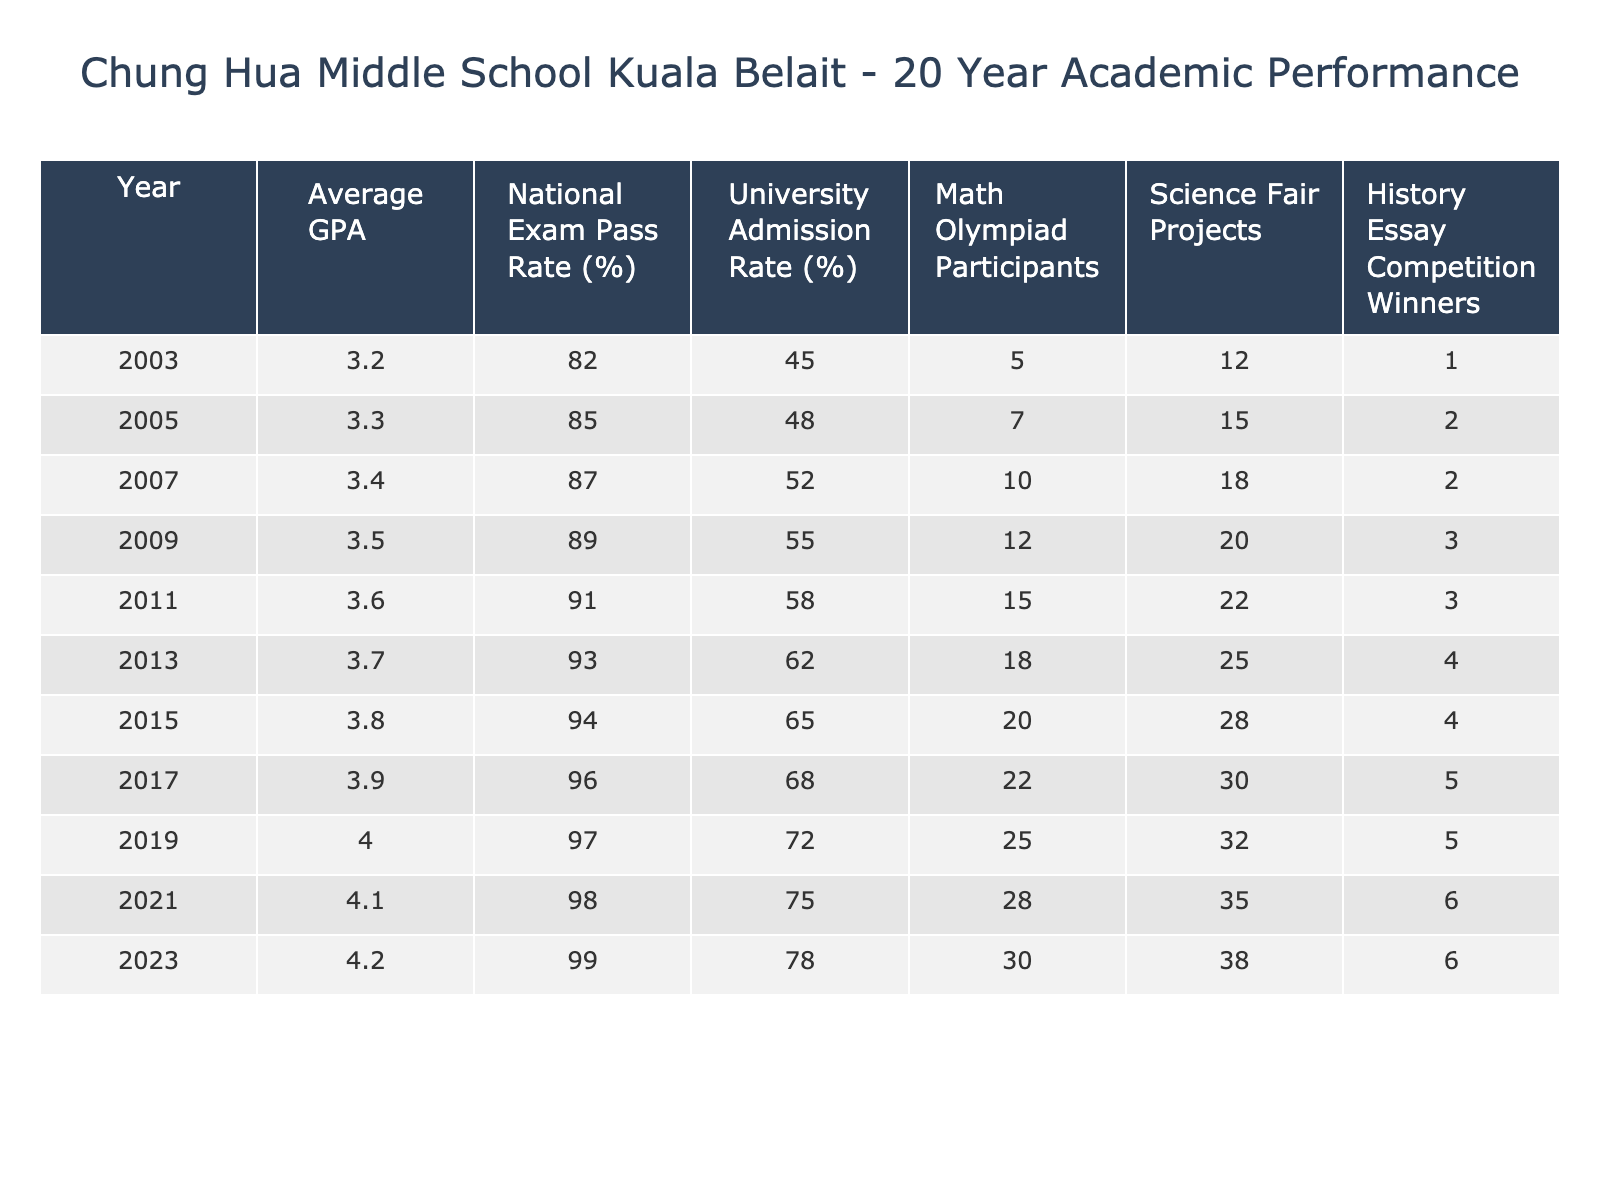What was the highest average GPA recorded in the past 20 years? From the table, the average GPAs range from 3.2 in 2003 to 4.2 in 2023. The maximum value is 4.2, which is the highest recorded average GPA.
Answer: 4.2 In which year did the National Exam Pass Rate reach 96%? By examining the table, the National Exam Pass Rates increase every two years. The value of 96% correlates with the year 2017.
Answer: 2017 What is the difference in the average GPA between 2003 and 2023? The average GPA in 2003 is 3.2 and in 2023 it is 4.2. To find the difference, subtract 3.2 from 4.2, resulting in 1.0.
Answer: 1.0 How many years had a University Admission Rate of 70% or more? The University Admission Rate reached 70% in 2019 and continued to increase in successive years until 2023. Counting these years includes 2019, 2021, and 2023, making a total of 4 years (2019, 2021, 2023).
Answer: 4 What is the average number of Math Olympiad participants over the 20 years? To determine the average, sum the values of Math Olympiad Participants: (5 + 7 + 10 + 12 + 15 + 18 + 20 + 22 + 25 + 28 + 30) =  4.5 per year with 11 total years gives an average of 20 participants.
Answer: 20 In which year did the History Essay Competition Winners peak? Looking through the data, the number of winners increased each year, reaching a peak of 6 winners in 2021 and 2023.
Answer: 2021 and 2023 What is the total number of Science Fair Projects recorded in the past years? By summing the values of Science Fair Projects: (12 + 15 + 18 + 20 + 22 + 25 + 28 + 30 + 32 + 35 + 38) =  251.
Answer: 251 Was there ever a year when both the National Exam Pass Rate and University Admission Rate were less than 80%? Checking the data, the National Exam Pass Rate was below 80% in 2003, but the University Admission Rate was over 40% that year, so the statement is false.
Answer: No How much did the Math Olympiad participants increase from 2011 to 2021? The number of Math Olympiad participants in 2011 was 15, and in 2021 it was 28. The difference is 28 - 15 = 13 participants.
Answer: 13 Which year saw the lowest Science Fair Projects, and how many were there? By checking the table, 12 projects were noted in 2003, which stands out as the lowest.
Answer: 2003, 12 What is the overall trend in the average GPA from 2003 to 2023? A clear upward trend can be observed in the average GPA, increasing from 3.2 in 2003 to 4.2 in 2023, suggesting improvement in academic performance.
Answer: Upward trend 